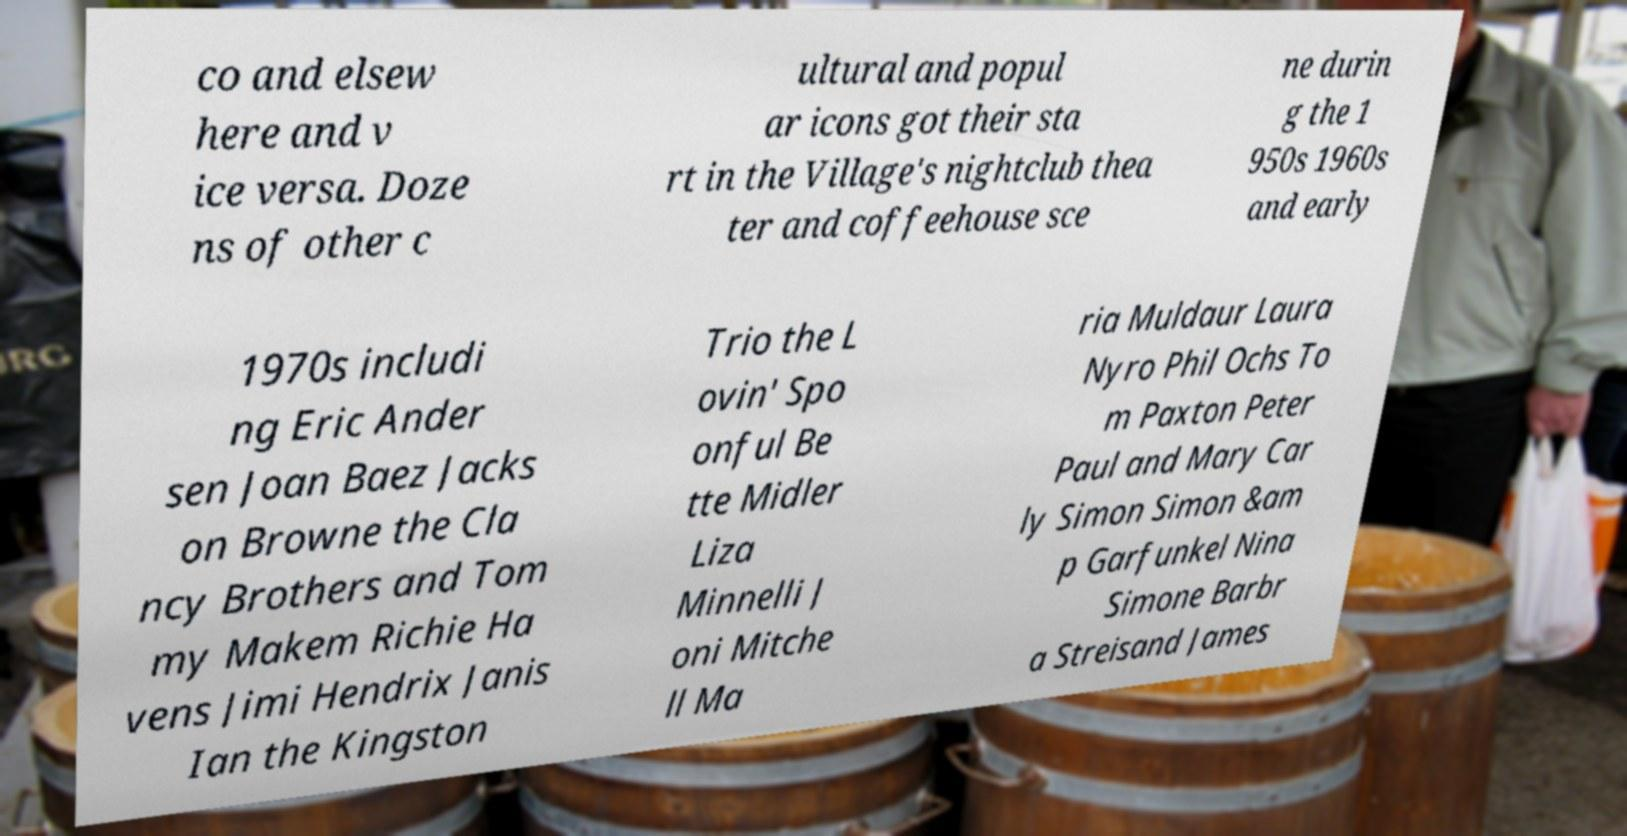I need the written content from this picture converted into text. Can you do that? co and elsew here and v ice versa. Doze ns of other c ultural and popul ar icons got their sta rt in the Village's nightclub thea ter and coffeehouse sce ne durin g the 1 950s 1960s and early 1970s includi ng Eric Ander sen Joan Baez Jacks on Browne the Cla ncy Brothers and Tom my Makem Richie Ha vens Jimi Hendrix Janis Ian the Kingston Trio the L ovin' Spo onful Be tte Midler Liza Minnelli J oni Mitche ll Ma ria Muldaur Laura Nyro Phil Ochs To m Paxton Peter Paul and Mary Car ly Simon Simon &am p Garfunkel Nina Simone Barbr a Streisand James 